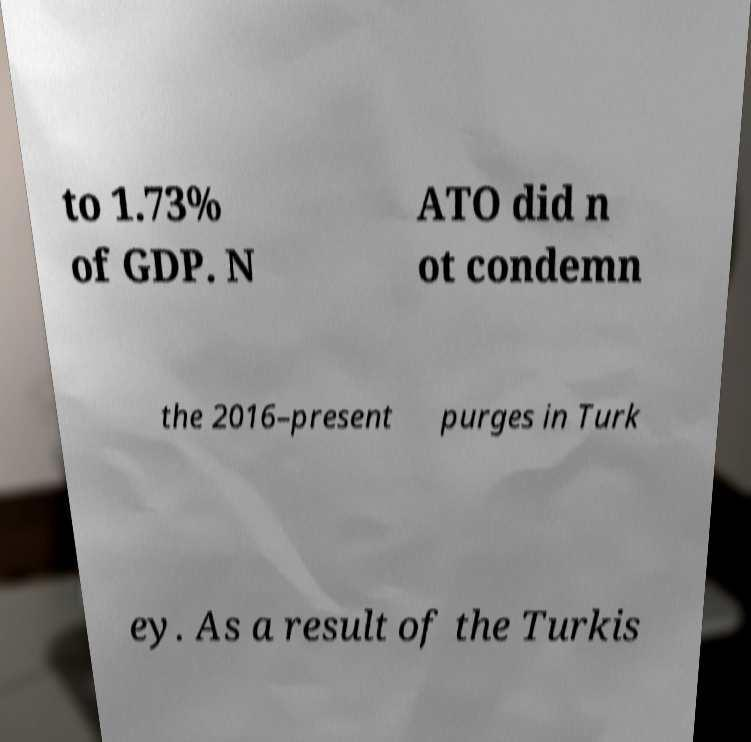For documentation purposes, I need the text within this image transcribed. Could you provide that? to 1.73% of GDP. N ATO did n ot condemn the 2016–present purges in Turk ey. As a result of the Turkis 